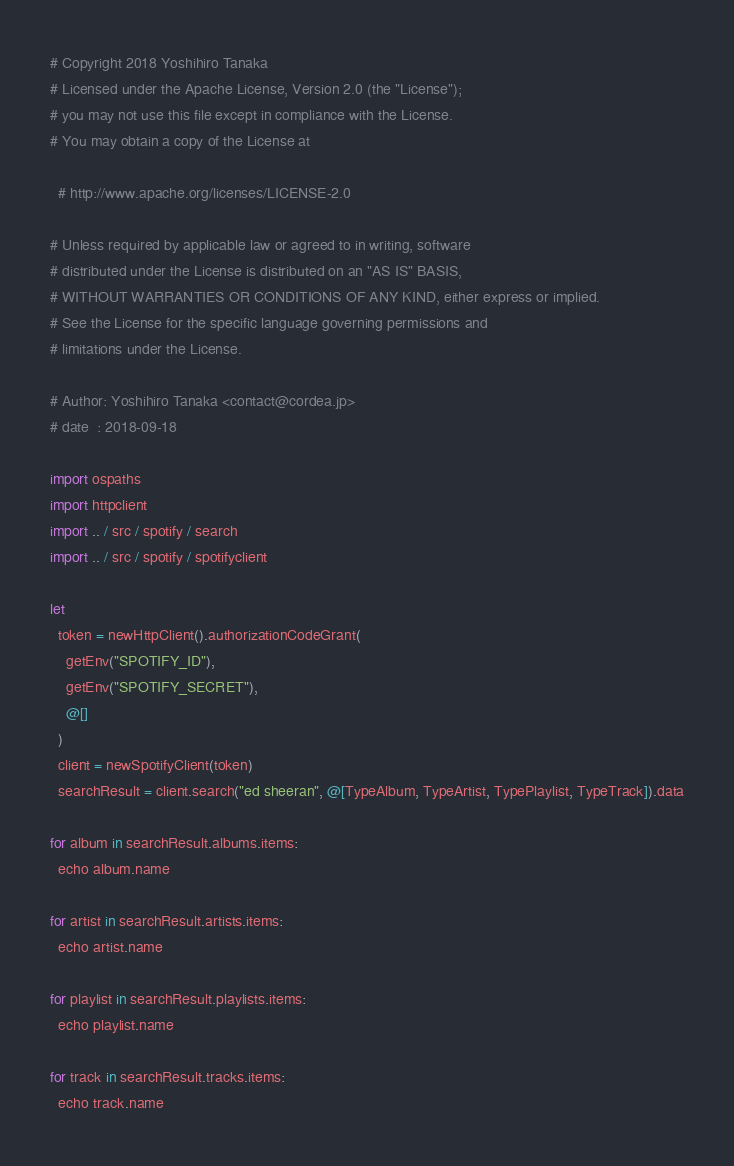Convert code to text. <code><loc_0><loc_0><loc_500><loc_500><_Nim_># Copyright 2018 Yoshihiro Tanaka
# Licensed under the Apache License, Version 2.0 (the "License");
# you may not use this file except in compliance with the License.
# You may obtain a copy of the License at

  # http://www.apache.org/licenses/LICENSE-2.0

# Unless required by applicable law or agreed to in writing, software
# distributed under the License is distributed on an "AS IS" BASIS,
# WITHOUT WARRANTIES OR CONDITIONS OF ANY KIND, either express or implied.
# See the License for the specific language governing permissions and
# limitations under the License.

# Author: Yoshihiro Tanaka <contact@cordea.jp>
# date  : 2018-09-18

import ospaths
import httpclient
import .. / src / spotify / search
import .. / src / spotify / spotifyclient

let
  token = newHttpClient().authorizationCodeGrant(
    getEnv("SPOTIFY_ID"),
    getEnv("SPOTIFY_SECRET"),
    @[]
  )
  client = newSpotifyClient(token)
  searchResult = client.search("ed sheeran", @[TypeAlbum, TypeArtist, TypePlaylist, TypeTrack]).data

for album in searchResult.albums.items:
  echo album.name

for artist in searchResult.artists.items:
  echo artist.name

for playlist in searchResult.playlists.items:
  echo playlist.name

for track in searchResult.tracks.items:
  echo track.name
</code> 